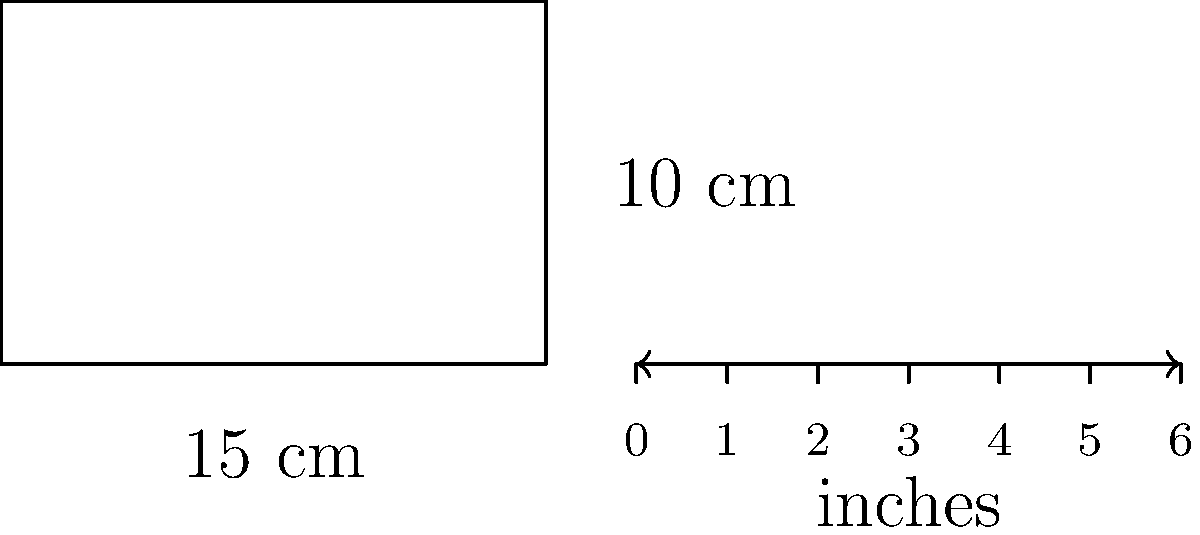A treasure box in your classroom measures 15 cm in length and 10 cm in height. If you need to express these dimensions in inches for a craft project, and 1 inch is approximately equal to 2.54 cm, what are the dimensions of the treasure box in inches? Round your answer to the nearest quarter inch. Let's approach this step-by-step:

1) First, let's convert the length from cm to inches:
   $15 \text{ cm} \div 2.54 \text{ cm/inch} = 5.905512 \text{ inches}$

2) Now, let's convert the height from cm to inches:
   $10 \text{ cm} \div 2.54 \text{ cm/inch} = 3.937008 \text{ inches}$

3) We need to round these values to the nearest quarter inch. 
   In decimal form, quarter inches are represented as:
   0.25, 0.50, 0.75, 1.00

4) For the length (5.905512 inches):
   5.75 < 5.905512 < 6.00
   So, we round to 6 inches

5) For the height (3.937008 inches):
   3.75 < 3.937008 < 4.00
   So, we round to 4 inches

Therefore, the dimensions of the treasure box, when expressed in inches and rounded to the nearest quarter inch, are 6 inches in length and 4 inches in height.
Answer: $6 \text{ inches} \times 4 \text{ inches}$ 